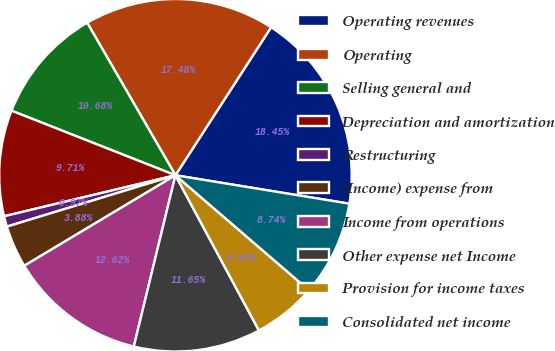Convert chart to OTSL. <chart><loc_0><loc_0><loc_500><loc_500><pie_chart><fcel>Operating revenues<fcel>Operating<fcel>Selling general and<fcel>Depreciation and amortization<fcel>Restructuring<fcel>(Income) expense from<fcel>Income from operations<fcel>Other expense net Income<fcel>Provision for income taxes<fcel>Consolidated net income<nl><fcel>18.45%<fcel>17.48%<fcel>10.68%<fcel>9.71%<fcel>0.97%<fcel>3.88%<fcel>12.62%<fcel>11.65%<fcel>5.83%<fcel>8.74%<nl></chart> 